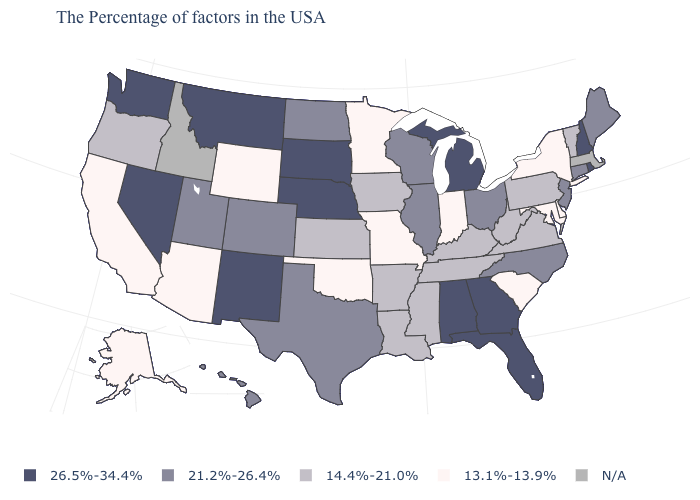Does South Dakota have the lowest value in the USA?
Answer briefly. No. Does the map have missing data?
Concise answer only. Yes. Among the states that border Washington , which have the lowest value?
Be succinct. Oregon. What is the value of North Carolina?
Keep it brief. 21.2%-26.4%. What is the value of Oregon?
Answer briefly. 14.4%-21.0%. Which states have the lowest value in the USA?
Be succinct. New York, Delaware, Maryland, South Carolina, Indiana, Missouri, Minnesota, Oklahoma, Wyoming, Arizona, California, Alaska. What is the value of Mississippi?
Be succinct. 14.4%-21.0%. Which states have the lowest value in the USA?
Concise answer only. New York, Delaware, Maryland, South Carolina, Indiana, Missouri, Minnesota, Oklahoma, Wyoming, Arizona, California, Alaska. Does the map have missing data?
Keep it brief. Yes. What is the value of Oklahoma?
Answer briefly. 13.1%-13.9%. What is the value of Oregon?
Answer briefly. 14.4%-21.0%. What is the lowest value in states that border Georgia?
Be succinct. 13.1%-13.9%. Name the states that have a value in the range 26.5%-34.4%?
Short answer required. Rhode Island, New Hampshire, Florida, Georgia, Michigan, Alabama, Nebraska, South Dakota, New Mexico, Montana, Nevada, Washington. What is the value of Kentucky?
Write a very short answer. 14.4%-21.0%. Name the states that have a value in the range 21.2%-26.4%?
Keep it brief. Maine, Connecticut, New Jersey, North Carolina, Ohio, Wisconsin, Illinois, Texas, North Dakota, Colorado, Utah, Hawaii. 